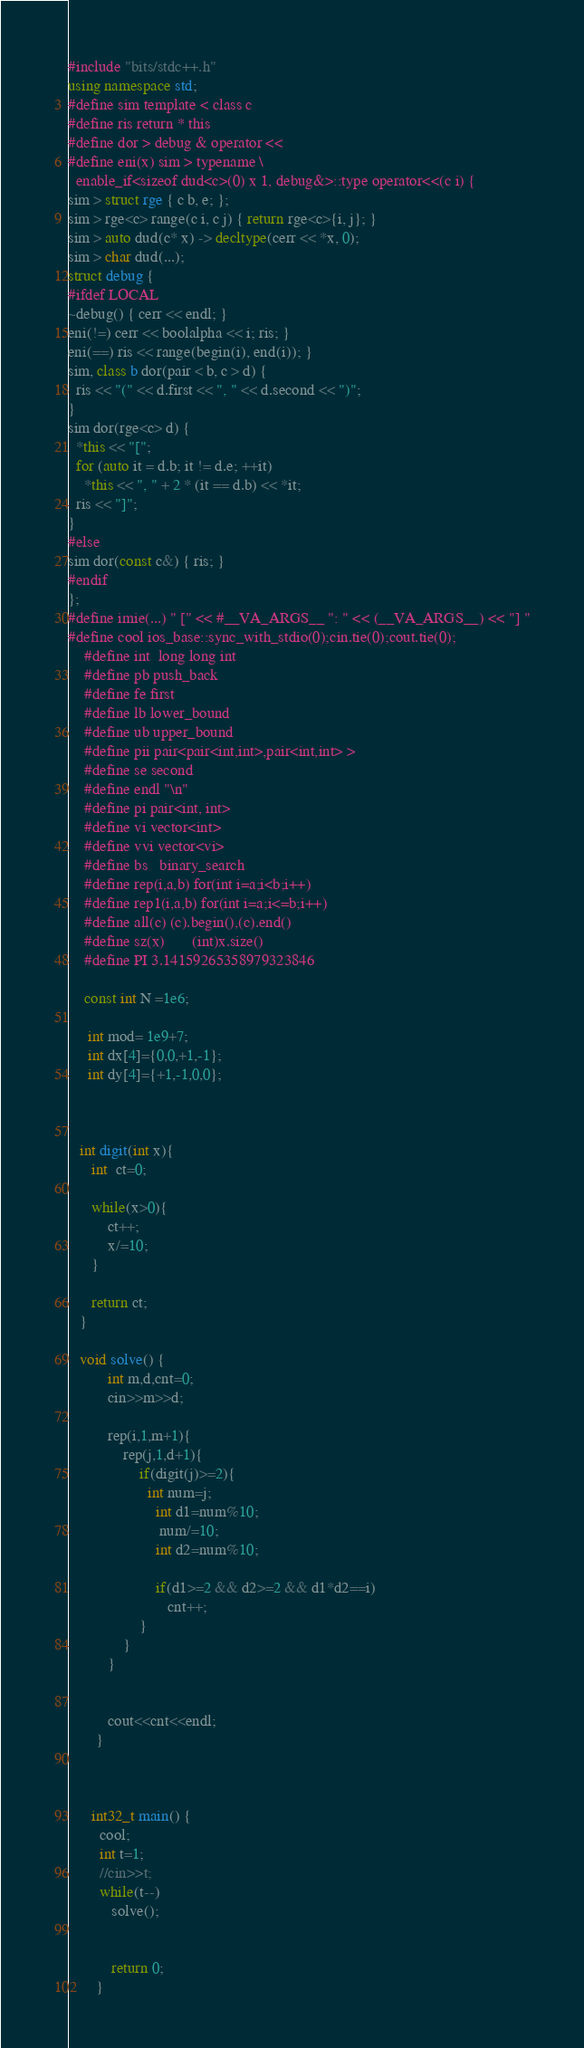Convert code to text. <code><loc_0><loc_0><loc_500><loc_500><_C++_>#include "bits/stdc++.h"
using namespace std;
#define sim template < class c
#define ris return * this
#define dor > debug & operator <<
#define eni(x) sim > typename \
  enable_if<sizeof dud<c>(0) x 1, debug&>::type operator<<(c i) {
sim > struct rge { c b, e; };
sim > rge<c> range(c i, c j) { return rge<c>{i, j}; }
sim > auto dud(c* x) -> decltype(cerr << *x, 0);
sim > char dud(...);
struct debug {
#ifdef LOCAL
~debug() { cerr << endl; }
eni(!=) cerr << boolalpha << i; ris; }
eni(==) ris << range(begin(i), end(i)); }
sim, class b dor(pair < b, c > d) {
  ris << "(" << d.first << ", " << d.second << ")";
}
sim dor(rge<c> d) {
  *this << "[";
  for (auto it = d.b; it != d.e; ++it)
    *this << ", " + 2 * (it == d.b) << *it;
  ris << "]";
}
#else
sim dor(const c&) { ris; }
#endif
};
#define imie(...) " [" << #__VA_ARGS__ ": " << (__VA_ARGS__) << "] "
#define cool ios_base::sync_with_stdio(0);cin.tie(0);cout.tie(0);
	#define int  long long int
	#define pb push_back
	#define fe first
    #define lb lower_bound 
    #define ub upper_bound
    #define pii pair<pair<int,int>,pair<int,int> >
	#define se second
	#define endl "\n"
	#define pi pair<int, int>
	#define vi vector<int> 
	#define vvi vector<vi>
    #define bs   binary_search
	#define rep(i,a,b) for(int i=a;i<b;i++)
	#define rep1(i,a,b) for(int i=a;i<=b;i++)	
    #define all(c) (c).begin(),(c).end()
    #define sz(x)       (int)x.size() 
	#define PI 3.14159265358979323846
    
	const int N =1e6;
    
     int mod= 1e9+7;
     int dx[4]={0,0,+1,-1};
     int dy[4]={+1,-1,0,0};
   
   
   
   int digit(int x){
      int  ct=0;
      
      while(x>0){
          ct++;
          x/=10;
      }
      
      return ct;
   }
   
   void solve() {
	      int m,d,cnt=0;
          cin>>m>>d;
          
          rep(i,1,m+1){
              rep(j,1,d+1){
                  if(digit(j)>=2){
                    int num=j;
                      int d1=num%10;
                       num/=10;
                      int d2=num%10;
                      
                      if(d1>=2 && d2>=2 && d1*d2==i)
                         cnt++; 
                  }
              }
          }
          
          
          cout<<cnt<<endl;
       }
   
   
   
      int32_t main() {
	    cool;
	    int t=1;
        //cin>>t;
	    while(t--)
	       solve();
	       
	       
	       return 0;	   
	   }
</code> 